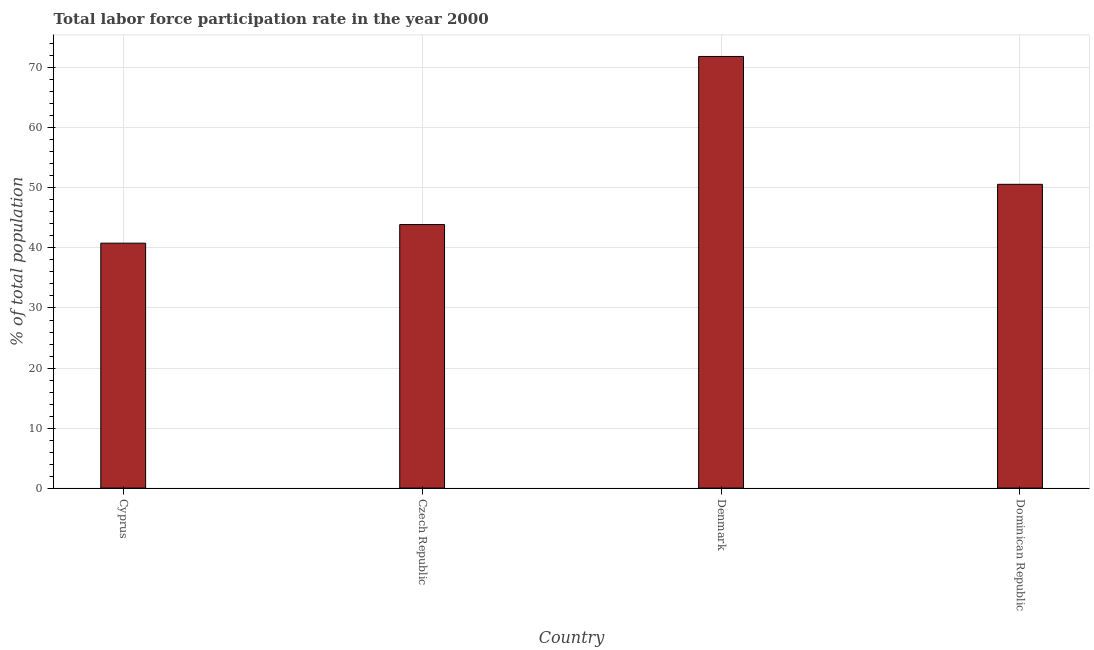Does the graph contain any zero values?
Make the answer very short. No. What is the title of the graph?
Your answer should be compact. Total labor force participation rate in the year 2000. What is the label or title of the X-axis?
Give a very brief answer. Country. What is the label or title of the Y-axis?
Your answer should be compact. % of total population. What is the total labor force participation rate in Dominican Republic?
Your answer should be very brief. 50.6. Across all countries, what is the maximum total labor force participation rate?
Make the answer very short. 71.9. Across all countries, what is the minimum total labor force participation rate?
Give a very brief answer. 40.8. In which country was the total labor force participation rate maximum?
Offer a terse response. Denmark. In which country was the total labor force participation rate minimum?
Ensure brevity in your answer.  Cyprus. What is the sum of the total labor force participation rate?
Give a very brief answer. 207.2. What is the average total labor force participation rate per country?
Make the answer very short. 51.8. What is the median total labor force participation rate?
Your answer should be very brief. 47.25. What is the ratio of the total labor force participation rate in Cyprus to that in Denmark?
Provide a short and direct response. 0.57. Is the difference between the total labor force participation rate in Cyprus and Dominican Republic greater than the difference between any two countries?
Ensure brevity in your answer.  No. What is the difference between the highest and the second highest total labor force participation rate?
Offer a terse response. 21.3. Is the sum of the total labor force participation rate in Cyprus and Czech Republic greater than the maximum total labor force participation rate across all countries?
Keep it short and to the point. Yes. What is the difference between the highest and the lowest total labor force participation rate?
Offer a terse response. 31.1. In how many countries, is the total labor force participation rate greater than the average total labor force participation rate taken over all countries?
Your response must be concise. 1. How many bars are there?
Provide a short and direct response. 4. How many countries are there in the graph?
Give a very brief answer. 4. What is the difference between two consecutive major ticks on the Y-axis?
Make the answer very short. 10. Are the values on the major ticks of Y-axis written in scientific E-notation?
Keep it short and to the point. No. What is the % of total population of Cyprus?
Make the answer very short. 40.8. What is the % of total population of Czech Republic?
Ensure brevity in your answer.  43.9. What is the % of total population in Denmark?
Offer a very short reply. 71.9. What is the % of total population of Dominican Republic?
Offer a very short reply. 50.6. What is the difference between the % of total population in Cyprus and Czech Republic?
Your answer should be compact. -3.1. What is the difference between the % of total population in Cyprus and Denmark?
Offer a terse response. -31.1. What is the difference between the % of total population in Cyprus and Dominican Republic?
Give a very brief answer. -9.8. What is the difference between the % of total population in Czech Republic and Denmark?
Your answer should be compact. -28. What is the difference between the % of total population in Denmark and Dominican Republic?
Your answer should be very brief. 21.3. What is the ratio of the % of total population in Cyprus to that in Czech Republic?
Your answer should be compact. 0.93. What is the ratio of the % of total population in Cyprus to that in Denmark?
Your response must be concise. 0.57. What is the ratio of the % of total population in Cyprus to that in Dominican Republic?
Offer a very short reply. 0.81. What is the ratio of the % of total population in Czech Republic to that in Denmark?
Your response must be concise. 0.61. What is the ratio of the % of total population in Czech Republic to that in Dominican Republic?
Offer a terse response. 0.87. What is the ratio of the % of total population in Denmark to that in Dominican Republic?
Ensure brevity in your answer.  1.42. 